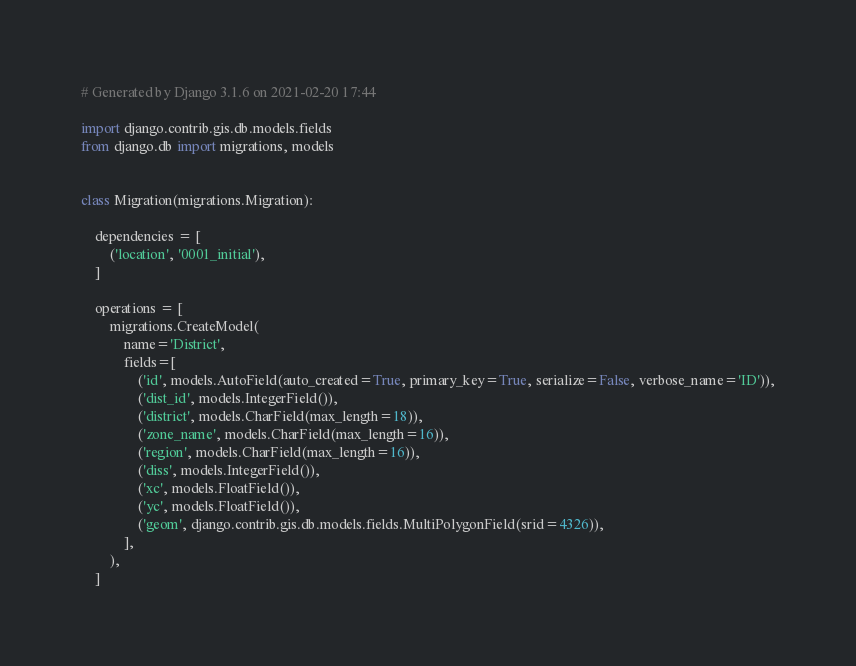Convert code to text. <code><loc_0><loc_0><loc_500><loc_500><_Python_># Generated by Django 3.1.6 on 2021-02-20 17:44

import django.contrib.gis.db.models.fields
from django.db import migrations, models


class Migration(migrations.Migration):

    dependencies = [
        ('location', '0001_initial'),
    ]

    operations = [
        migrations.CreateModel(
            name='District',
            fields=[
                ('id', models.AutoField(auto_created=True, primary_key=True, serialize=False, verbose_name='ID')),
                ('dist_id', models.IntegerField()),
                ('district', models.CharField(max_length=18)),
                ('zone_name', models.CharField(max_length=16)),
                ('region', models.CharField(max_length=16)),
                ('diss', models.IntegerField()),
                ('xc', models.FloatField()),
                ('yc', models.FloatField()),
                ('geom', django.contrib.gis.db.models.fields.MultiPolygonField(srid=4326)),
            ],
        ),
    ]
</code> 